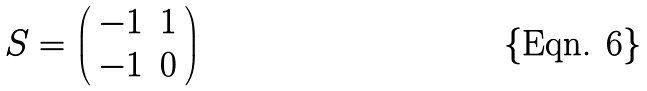Convert formula to latex. <formula><loc_0><loc_0><loc_500><loc_500>S = \left ( \begin{array} { c c } - 1 & 1 \\ - 1 & 0 \end{array} \right )</formula> 